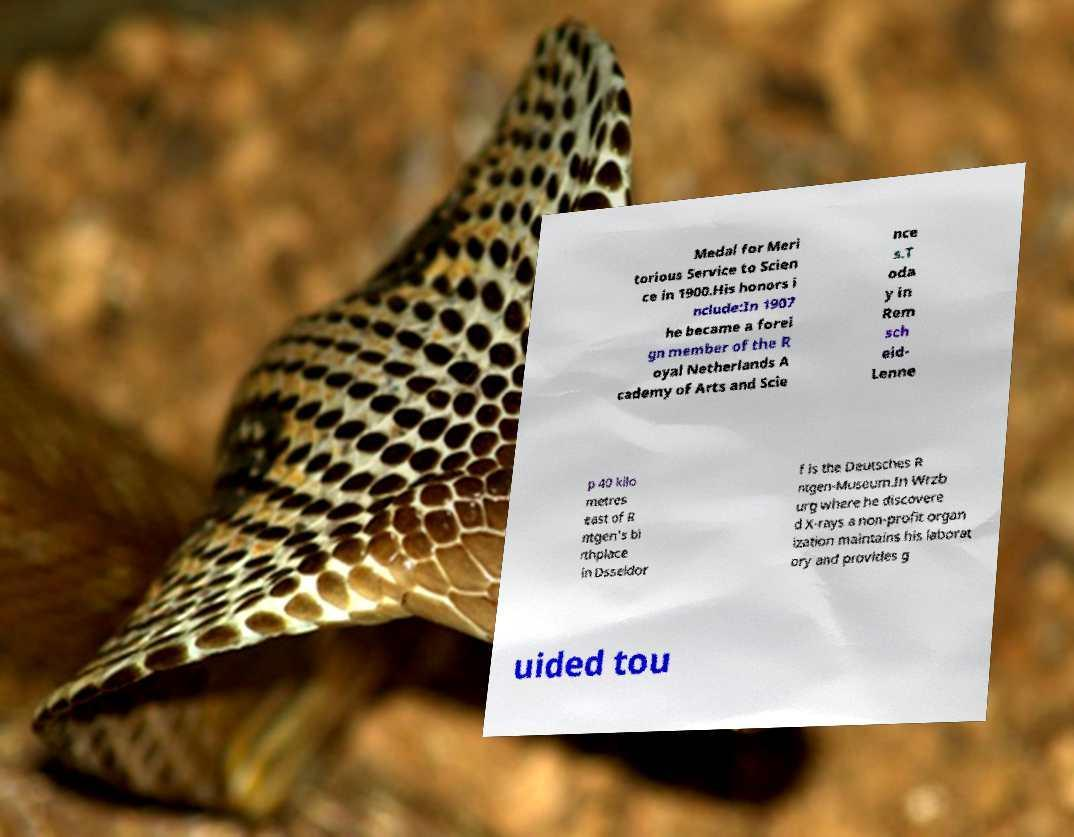I need the written content from this picture converted into text. Can you do that? Medal for Meri torious Service to Scien ce in 1900.His honors i nclude:In 1907 he became a forei gn member of the R oyal Netherlands A cademy of Arts and Scie nce s.T oda y in Rem sch eid- Lenne p 40 kilo metres east of R ntgen's bi rthplace in Dsseldor f is the Deutsches R ntgen-Museum.In Wrzb urg where he discovere d X-rays a non-profit organ ization maintains his laborat ory and provides g uided tou 